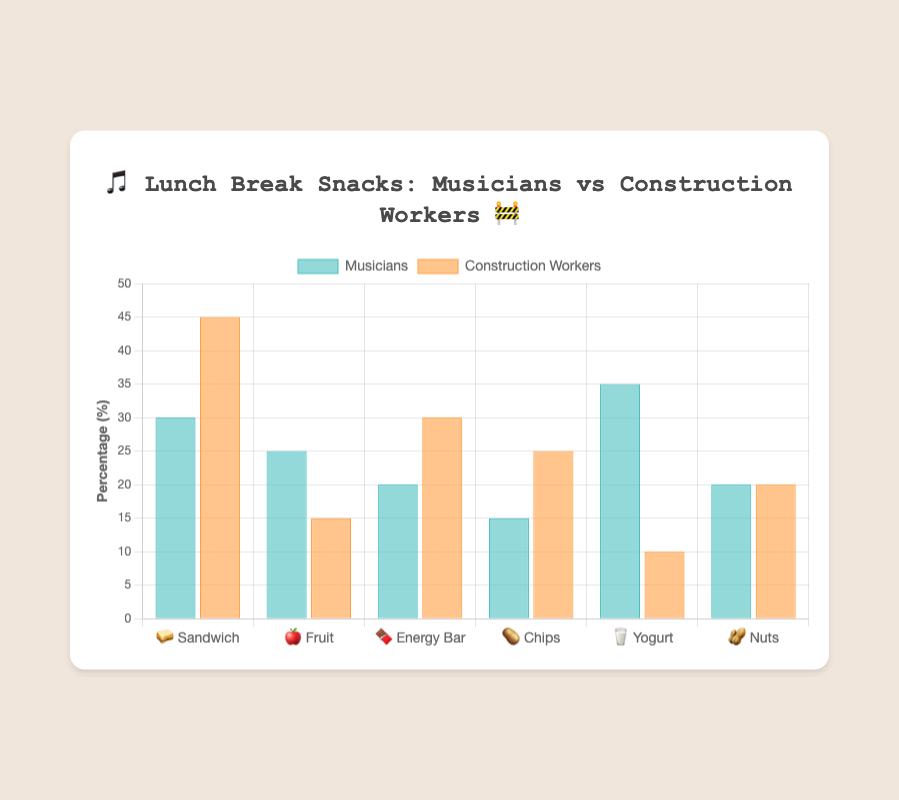Which group prefers sandwiches the most? 🥪 Look at the heights of the bars representing sandwich preferences. The “Construction Workers” bar is taller.
Answer: Construction Workers How many more musicians prefer yogurt compared to construction workers? 🥛 The bar for musicians liking yogurt is at 35%, while for construction workers it is at 10%. Subtract 10 from 35 to get the difference.
Answer: 25% Which snack is equally popular among both group? 🥜 Find the bar pairs that are of equal height; the bars for nuts are both at 20%.
Answer: Nuts Which snack has the largest difference in preference between musicians and construction workers? Compare differences for each snack. Yogurt has the largest difference of 25% (35% - 10%).
Answer: Yogurt What is the second most preferred snack among construction workers? Look at the bars representing construction workers' preferences. Energy bars are second tallest after sandwiches.
Answer: Energy Bar If you combined the preferences for chips for both groups, what percentage would you get? 🥔 Add the percentages: 15% for musicians and 25% for construction workers. 15% + 25% = 40%.
Answer: 40% Which group prefers fruits more, and by how much? 🍎 Compare the fruits' bar heights. Musicians prefer fruits more by 25% - 15% = 10%.
Answer: Musicians by 10% Is the popularity of energy bars 🍫 higher among musicians or construction workers? Look at the heights of the bars for energy bars. The construction workers' bar is taller at 30%.
Answer: Construction Workers What's the title of the chart? The title is clearly written at the top of the chart.
Answer: “Lunch Break Snacks: Musicians vs Construction Workers” 